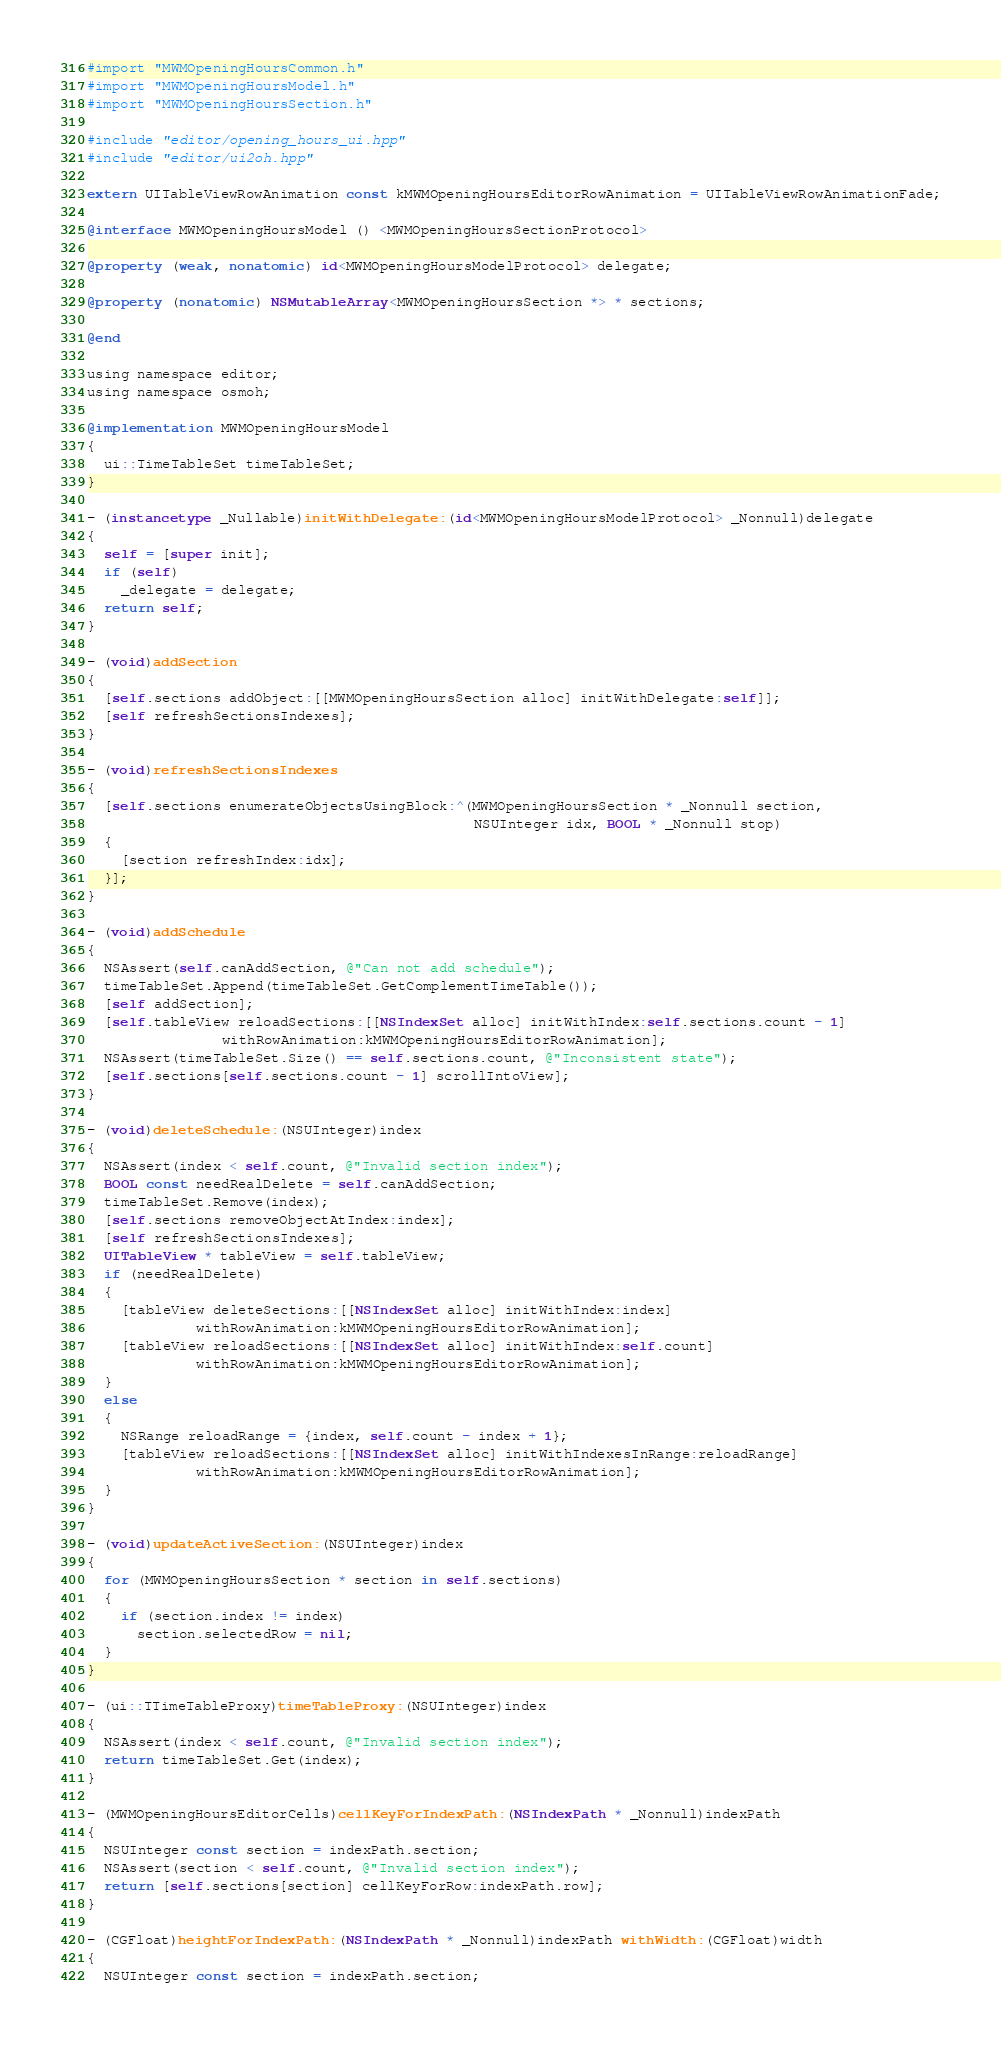<code> <loc_0><loc_0><loc_500><loc_500><_ObjectiveC_>#import "MWMOpeningHoursCommon.h"
#import "MWMOpeningHoursModel.h"
#import "MWMOpeningHoursSection.h"

#include "editor/opening_hours_ui.hpp"
#include "editor/ui2oh.hpp"

extern UITableViewRowAnimation const kMWMOpeningHoursEditorRowAnimation = UITableViewRowAnimationFade;

@interface MWMOpeningHoursModel () <MWMOpeningHoursSectionProtocol>

@property (weak, nonatomic) id<MWMOpeningHoursModelProtocol> delegate;

@property (nonatomic) NSMutableArray<MWMOpeningHoursSection *> * sections;

@end

using namespace editor;
using namespace osmoh;

@implementation MWMOpeningHoursModel
{
  ui::TimeTableSet timeTableSet;
}

- (instancetype _Nullable)initWithDelegate:(id<MWMOpeningHoursModelProtocol> _Nonnull)delegate
{
  self = [super init];
  if (self)
    _delegate = delegate;
  return self;
}

- (void)addSection
{
  [self.sections addObject:[[MWMOpeningHoursSection alloc] initWithDelegate:self]];
  [self refreshSectionsIndexes];
}

- (void)refreshSectionsIndexes
{
  [self.sections enumerateObjectsUsingBlock:^(MWMOpeningHoursSection * _Nonnull section,
                                              NSUInteger idx, BOOL * _Nonnull stop)
  {
    [section refreshIndex:idx];
  }];
}

- (void)addSchedule
{
  NSAssert(self.canAddSection, @"Can not add schedule");
  timeTableSet.Append(timeTableSet.GetComplementTimeTable());
  [self addSection];
  [self.tableView reloadSections:[[NSIndexSet alloc] initWithIndex:self.sections.count - 1]
                withRowAnimation:kMWMOpeningHoursEditorRowAnimation];
  NSAssert(timeTableSet.Size() == self.sections.count, @"Inconsistent state");
  [self.sections[self.sections.count - 1] scrollIntoView];
}

- (void)deleteSchedule:(NSUInteger)index
{
  NSAssert(index < self.count, @"Invalid section index");
  BOOL const needRealDelete = self.canAddSection;
  timeTableSet.Remove(index);
  [self.sections removeObjectAtIndex:index];
  [self refreshSectionsIndexes];
  UITableView * tableView = self.tableView;
  if (needRealDelete)
  {
    [tableView deleteSections:[[NSIndexSet alloc] initWithIndex:index]
             withRowAnimation:kMWMOpeningHoursEditorRowAnimation];
    [tableView reloadSections:[[NSIndexSet alloc] initWithIndex:self.count]
             withRowAnimation:kMWMOpeningHoursEditorRowAnimation];
  }
  else
  {
    NSRange reloadRange = {index, self.count - index + 1};
    [tableView reloadSections:[[NSIndexSet alloc] initWithIndexesInRange:reloadRange]
             withRowAnimation:kMWMOpeningHoursEditorRowAnimation];
  }
}

- (void)updateActiveSection:(NSUInteger)index
{
  for (MWMOpeningHoursSection * section in self.sections)
  {
    if (section.index != index)
      section.selectedRow = nil;
  }
}

- (ui::TTimeTableProxy)timeTableProxy:(NSUInteger)index
{
  NSAssert(index < self.count, @"Invalid section index");
  return timeTableSet.Get(index);
}

- (MWMOpeningHoursEditorCells)cellKeyForIndexPath:(NSIndexPath * _Nonnull)indexPath
{
  NSUInteger const section = indexPath.section;
  NSAssert(section < self.count, @"Invalid section index");
  return [self.sections[section] cellKeyForRow:indexPath.row];
}

- (CGFloat)heightForIndexPath:(NSIndexPath * _Nonnull)indexPath withWidth:(CGFloat)width
{
  NSUInteger const section = indexPath.section;</code> 